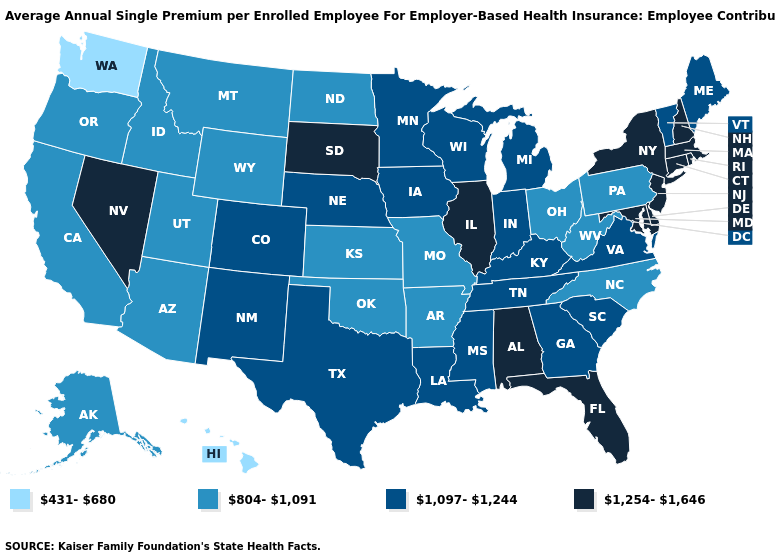Which states have the highest value in the USA?
Concise answer only. Alabama, Connecticut, Delaware, Florida, Illinois, Maryland, Massachusetts, Nevada, New Hampshire, New Jersey, New York, Rhode Island, South Dakota. Does the first symbol in the legend represent the smallest category?
Write a very short answer. Yes. What is the highest value in the West ?
Keep it brief. 1,254-1,646. Name the states that have a value in the range 431-680?
Short answer required. Hawaii, Washington. Name the states that have a value in the range 804-1,091?
Answer briefly. Alaska, Arizona, Arkansas, California, Idaho, Kansas, Missouri, Montana, North Carolina, North Dakota, Ohio, Oklahoma, Oregon, Pennsylvania, Utah, West Virginia, Wyoming. What is the value of West Virginia?
Give a very brief answer. 804-1,091. What is the lowest value in the MidWest?
Give a very brief answer. 804-1,091. What is the value of Maine?
Be succinct. 1,097-1,244. Does Florida have a higher value than New York?
Short answer required. No. What is the highest value in the USA?
Answer briefly. 1,254-1,646. Name the states that have a value in the range 1,254-1,646?
Short answer required. Alabama, Connecticut, Delaware, Florida, Illinois, Maryland, Massachusetts, Nevada, New Hampshire, New Jersey, New York, Rhode Island, South Dakota. Name the states that have a value in the range 431-680?
Concise answer only. Hawaii, Washington. Does Oregon have the same value as Pennsylvania?
Quick response, please. Yes. Name the states that have a value in the range 1,097-1,244?
Answer briefly. Colorado, Georgia, Indiana, Iowa, Kentucky, Louisiana, Maine, Michigan, Minnesota, Mississippi, Nebraska, New Mexico, South Carolina, Tennessee, Texas, Vermont, Virginia, Wisconsin. What is the highest value in states that border Massachusetts?
Concise answer only. 1,254-1,646. 